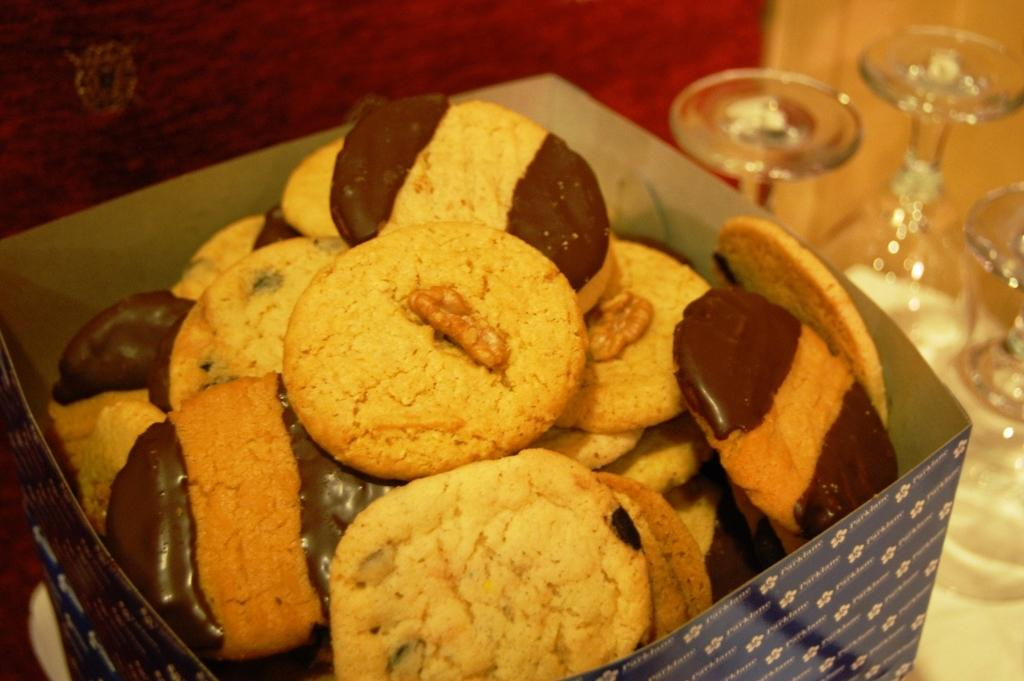What type of food item is in the box in the image? There are cookies in a box in the image. What can be used for drinking in the image? There are glasses visible in the image. What piece of furniture is present in the image? There is a table in the image. What type of loaf is being shared between friends in the image? There is no loaf or friends present in the image; it only features cookies in a box, glasses, and a table. 